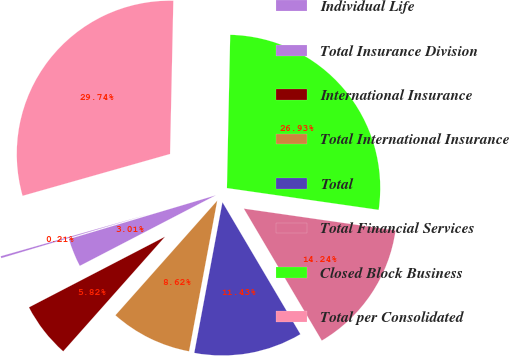<chart> <loc_0><loc_0><loc_500><loc_500><pie_chart><fcel>Individual Life<fcel>Total Insurance Division<fcel>International Insurance<fcel>Total International Insurance<fcel>Total<fcel>Total Financial Services<fcel>Closed Block Business<fcel>Total per Consolidated<nl><fcel>0.21%<fcel>3.01%<fcel>5.82%<fcel>8.62%<fcel>11.43%<fcel>14.24%<fcel>26.93%<fcel>29.74%<nl></chart> 